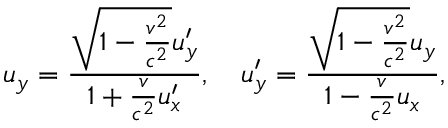Convert formula to latex. <formula><loc_0><loc_0><loc_500><loc_500>u _ { y } = { \frac { { \sqrt { 1 - { \frac { v ^ { 2 } } { c ^ { 2 } } } } } u _ { y } ^ { \prime } } { 1 + { \frac { v } { c ^ { 2 } } } u _ { x } ^ { \prime } } } , \quad u _ { y } ^ { \prime } = { \frac { { \sqrt { 1 - { \frac { v ^ { 2 } } { c ^ { 2 } } } } } u _ { y } } { 1 - { \frac { v } { c ^ { 2 } } } u _ { x } } } ,</formula> 